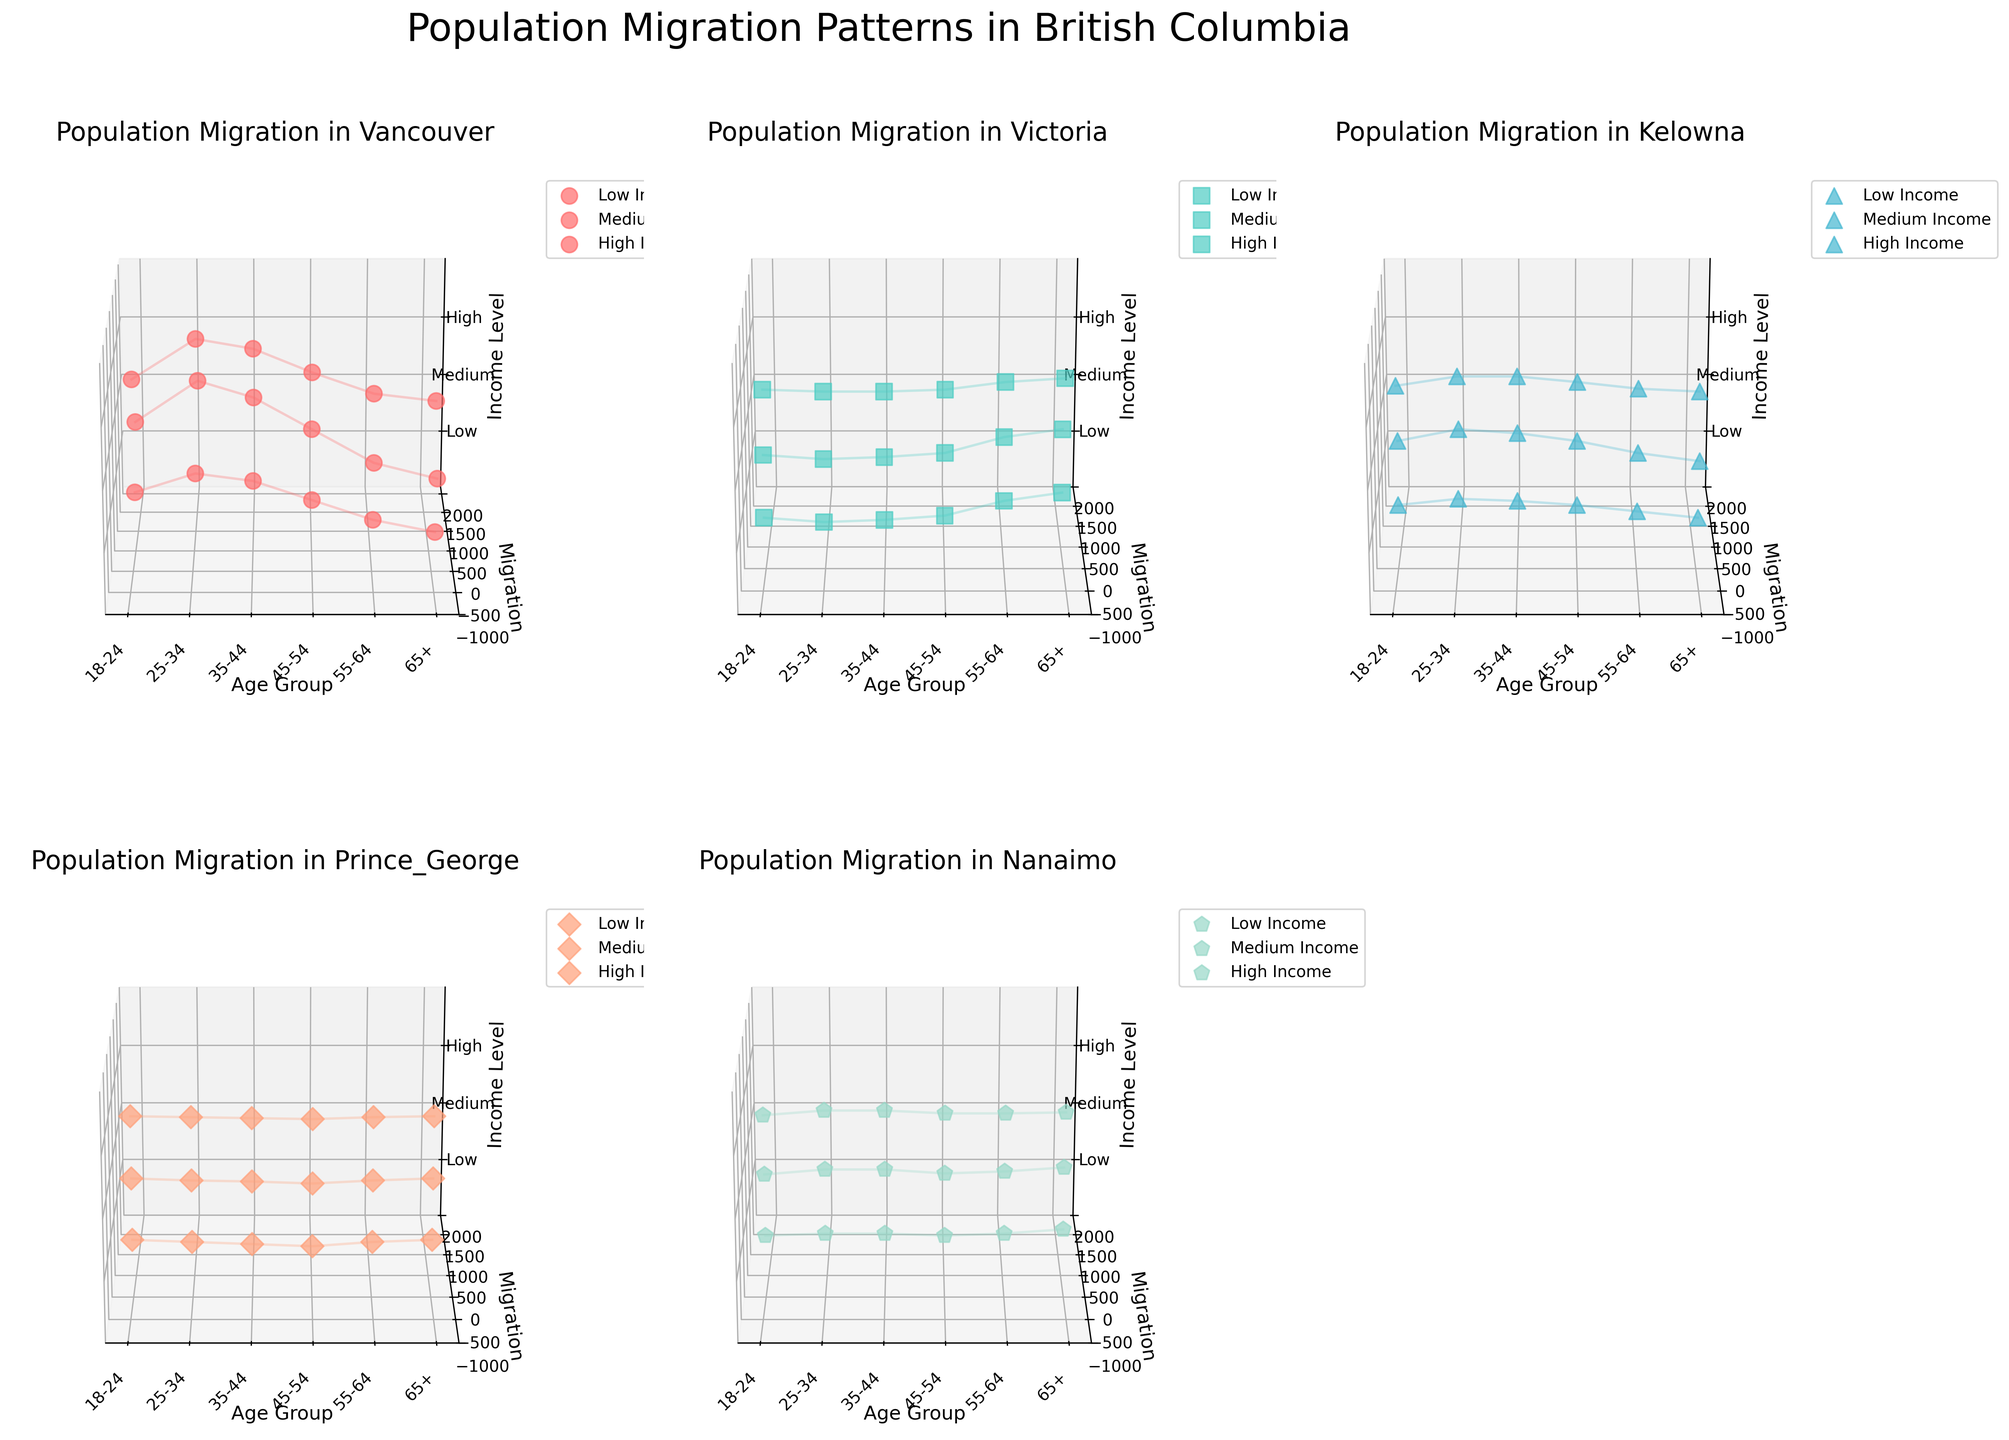How many cities are displayed in the plots? There are five subplots, each representing a different city (Vancouver, Victoria, Kelowna, Prince George, Nanaimo).
Answer: Five What is the migration pattern for the 25-34 age group with high income in Vancouver? In Vancouver, the plot shows that the 25-34 age group with high income has a migration number of 1500.
Answer: 1500 Among the given cities, which city shows a net positive migration for individuals aged 55-64 with a medium income level? By analyzing the 3D plots, we can see that Victoria has a net positive migration of 300, while other cities show negative or smaller positive values.
Answer: Victoria What is the common income level for negative migration patterns in Kelowna for the 18-24 age group? By examining the migration values in Kelowna for 18-24, negative values appear for low (-100) and medium (-150) income levels.
Answer: Low, Medium For the city of Nanaimo, which age group has the highest migration value for low-income individuals? In the Nanaimo subplot, the 25-34 age group has the highest migration value of 100 for low-income individuals.
Answer: 25-34 How does migration trend in Prince George differ between 45-54 age group and 65+ age group for high income? In Prince George, the 45-54 age group with high income shows a migration value of -75, while the 65+ age group shows a migration value of 0.
Answer: The migration difference is -75 versus 0 Which city has the largest migration figure for the medium income group in the 35-44 age range? For the medium-income group in the 35-44 age range, Vancouver has the largest migration figure at 1500.
Answer: Vancouver What are the migration values for low-income individuals aged 65+ across all cities? The 3D plot values for low-income individuals aged 65+ are: Vancouver (-500), Victoria (400), Kelowna (-200), Prince George (-50), and Nanaimo (200).
Answer: -500, 400, -200, -50, 200 